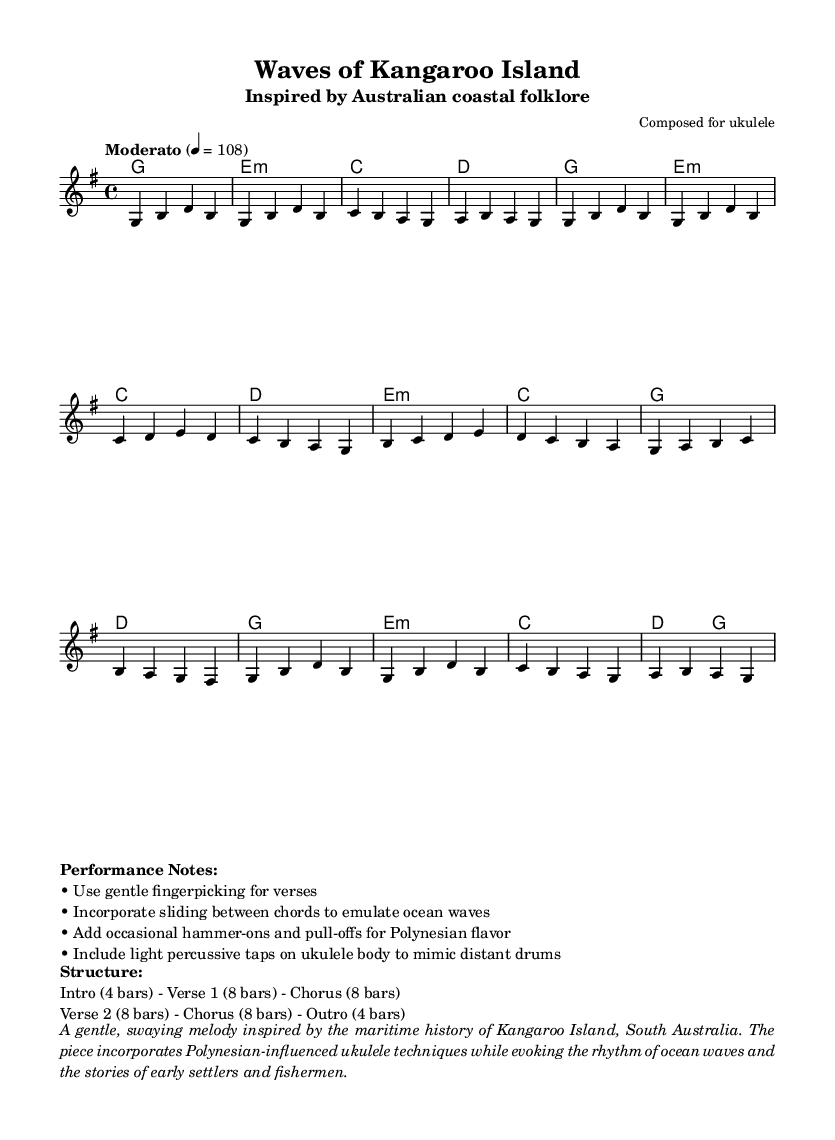What is the key signature of this music? The key signature indicated in the music sheet is G major, which has one sharp, specifically F#.
Answer: G major What is the time signature of this music? The time signature shown in the sheet music is 4/4, which means there are four beats in a measure and the quarter note receives one beat.
Answer: 4/4 What is the tempo marking for this piece? The tempo marking states "Moderato" with a metronome marking of 4 = 108, indicating a moderate tempo.
Answer: Moderato, 108 How many bars are in each verse? The sheet music details that each verse consists of 8 bars as found in the performance structure section.
Answer: 8 bars What unique ukulele techniques are suggested for performance? The performance notes suggest using gentle fingerpicking, sliding between chords, hammer-ons, and pull-offs to create a Polynesian flavor.
Answer: Fingerpicking, sliding, hammer-ons, pull-offs What emotions or themes does the music aim to evoke? The music aims to evoke a gentle sway inspired by the maritime history of Kangaroo Island, incorporating the rhythm of ocean waves and stories from early settlers and fishermen.
Answer: Maritime history and ocean waves 